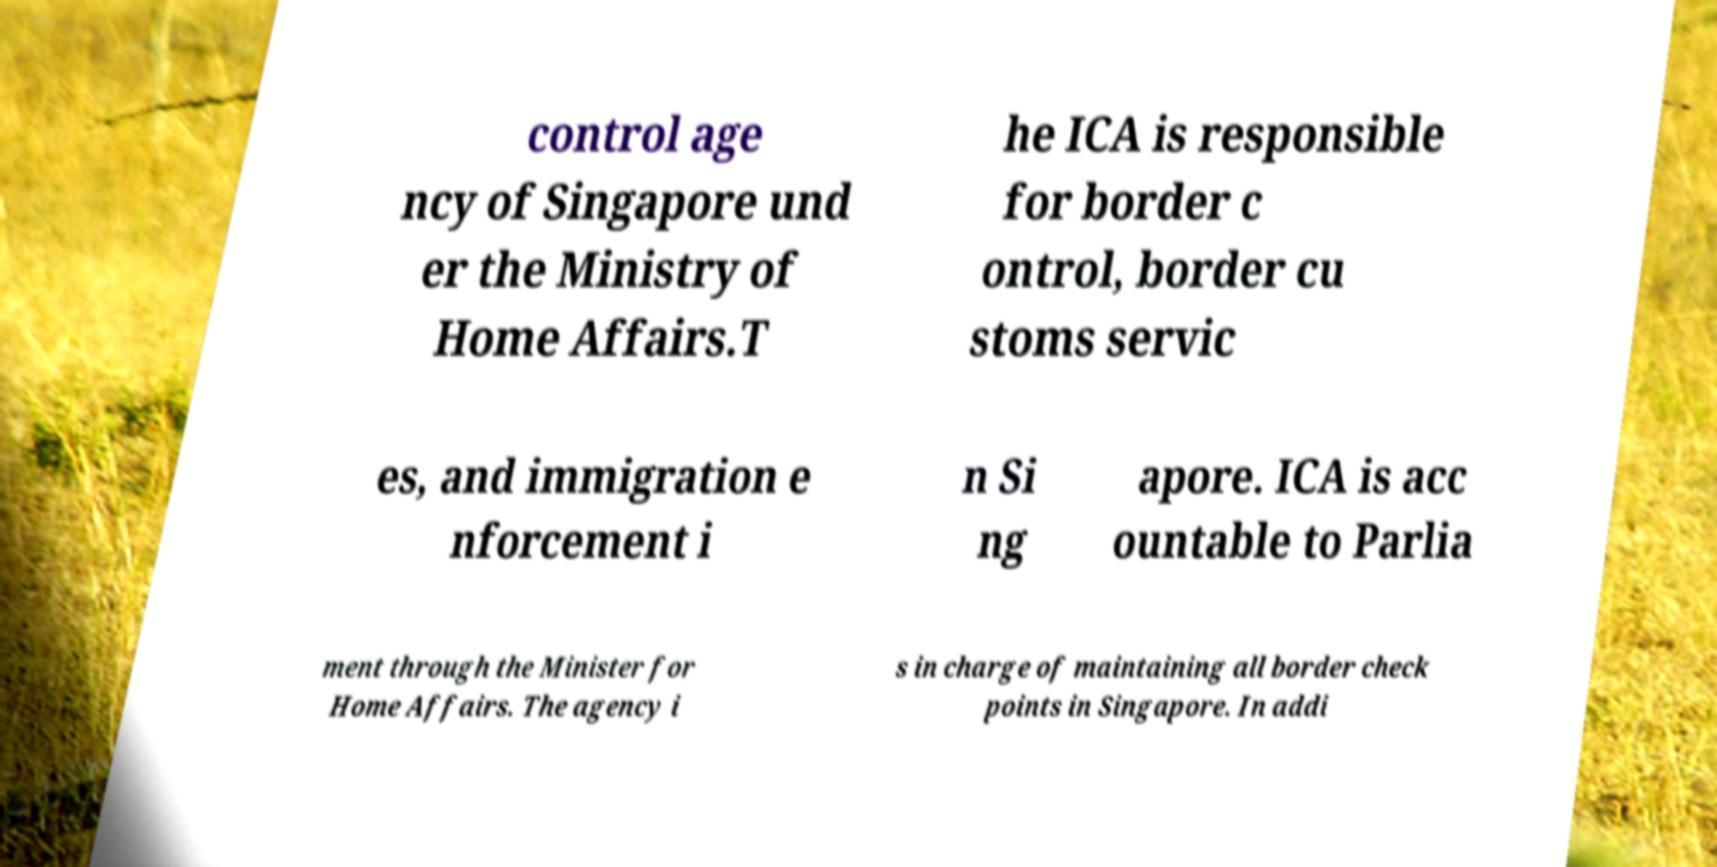Can you read and provide the text displayed in the image?This photo seems to have some interesting text. Can you extract and type it out for me? control age ncy of Singapore und er the Ministry of Home Affairs.T he ICA is responsible for border c ontrol, border cu stoms servic es, and immigration e nforcement i n Si ng apore. ICA is acc ountable to Parlia ment through the Minister for Home Affairs. The agency i s in charge of maintaining all border check points in Singapore. In addi 